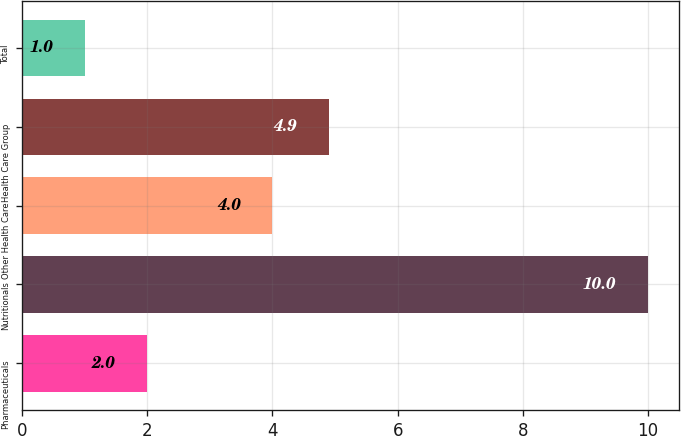Convert chart to OTSL. <chart><loc_0><loc_0><loc_500><loc_500><bar_chart><fcel>Pharmaceuticals<fcel>Nutritionals<fcel>Other Health Care<fcel>Health Care Group<fcel>Total<nl><fcel>2<fcel>10<fcel>4<fcel>4.9<fcel>1<nl></chart> 